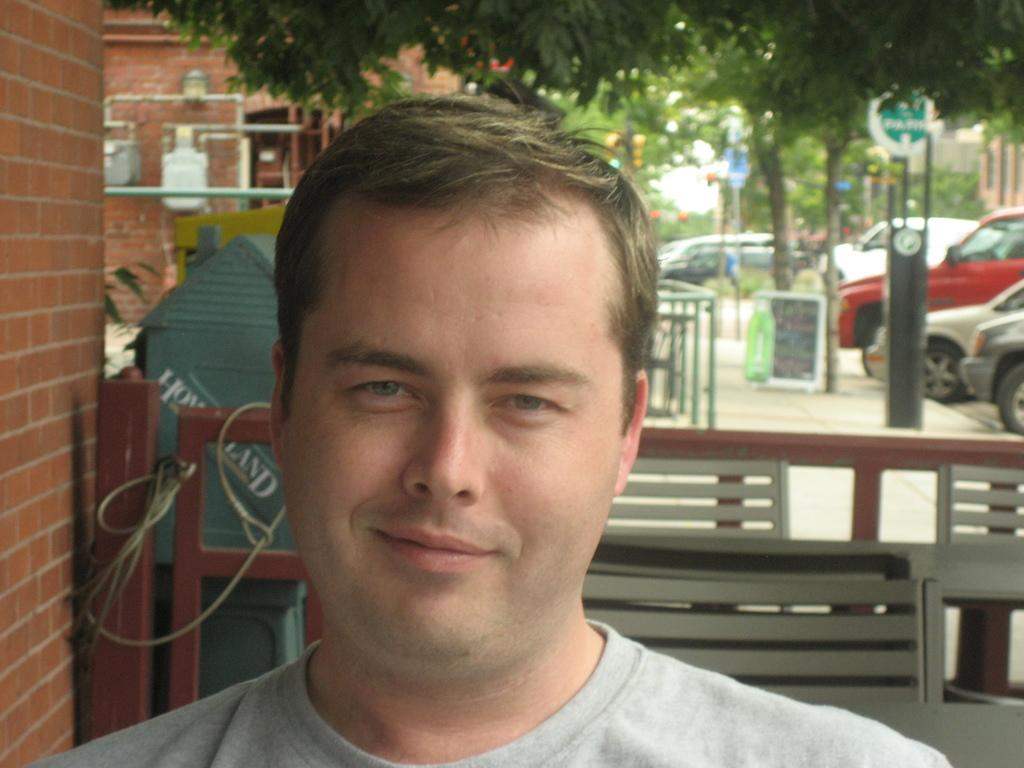Who is present in the image? There is a man in the image. What is the man's expression? The man is smiling. What can be seen in the background of the image? There are houses, trees, vehicles parked on a path, boards, poles, and iron rods in the background of the image. What type of button can be seen on the man's shirt in the image? There is no button visible on the man's shirt in the image. What kind of rice is being cooked in the background of the image? There is no rice or cooking activity present in the image. 